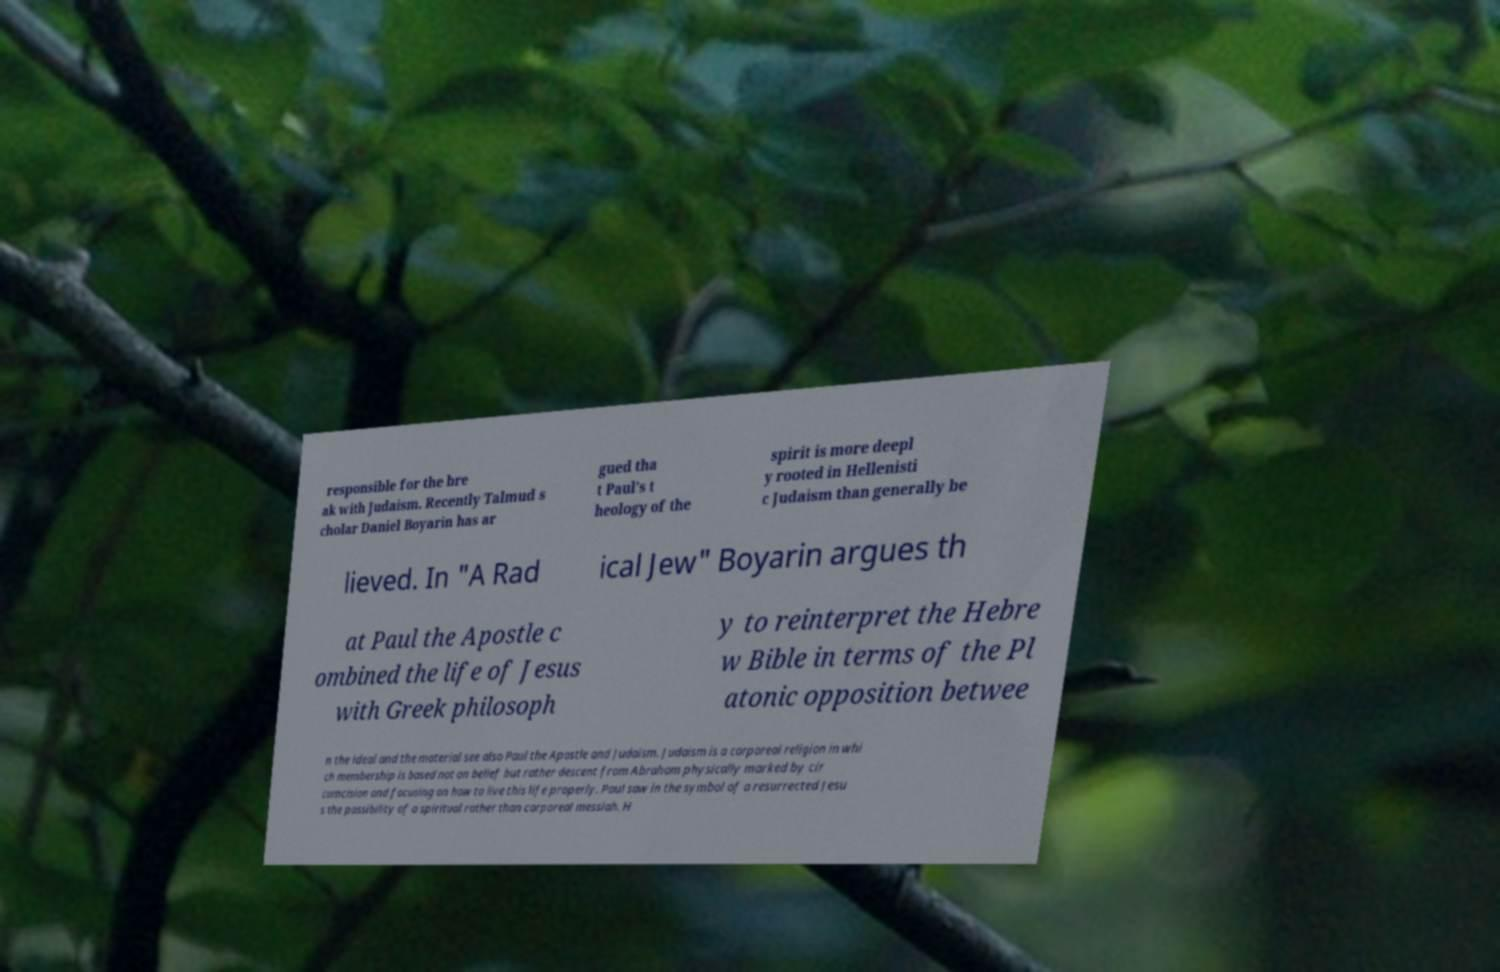There's text embedded in this image that I need extracted. Can you transcribe it verbatim? responsible for the bre ak with Judaism. Recently Talmud s cholar Daniel Boyarin has ar gued tha t Paul's t heology of the spirit is more deepl y rooted in Hellenisti c Judaism than generally be lieved. In "A Rad ical Jew" Boyarin argues th at Paul the Apostle c ombined the life of Jesus with Greek philosoph y to reinterpret the Hebre w Bible in terms of the Pl atonic opposition betwee n the ideal and the material see also Paul the Apostle and Judaism. Judaism is a corporeal religion in whi ch membership is based not on belief but rather descent from Abraham physically marked by cir cumcision and focusing on how to live this life properly. Paul saw in the symbol of a resurrected Jesu s the possibility of a spiritual rather than corporeal messiah. H 